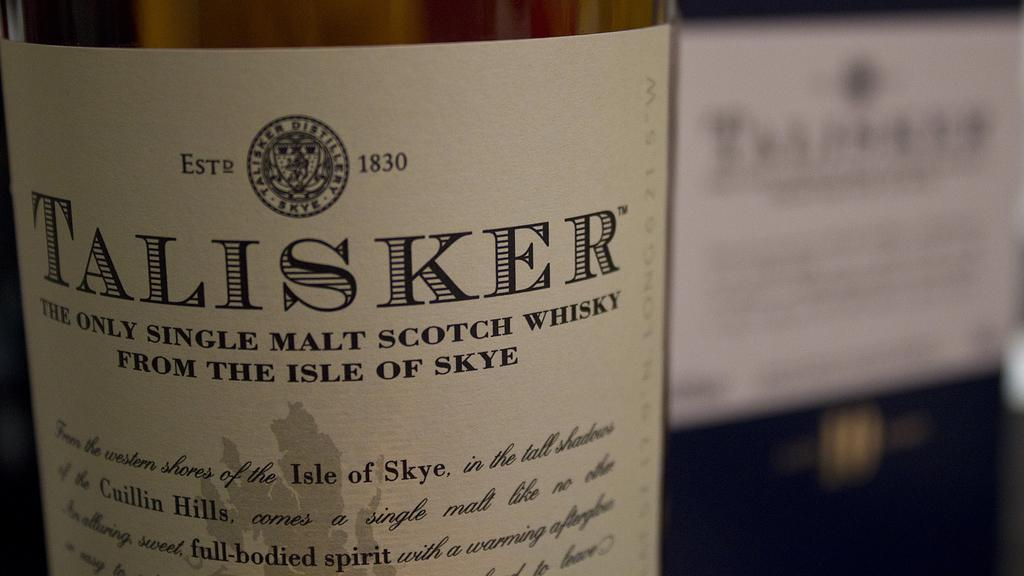<image>
Summarize the visual content of the image. A bottle of single malt scotch whisky came from the Isle of Skye. 